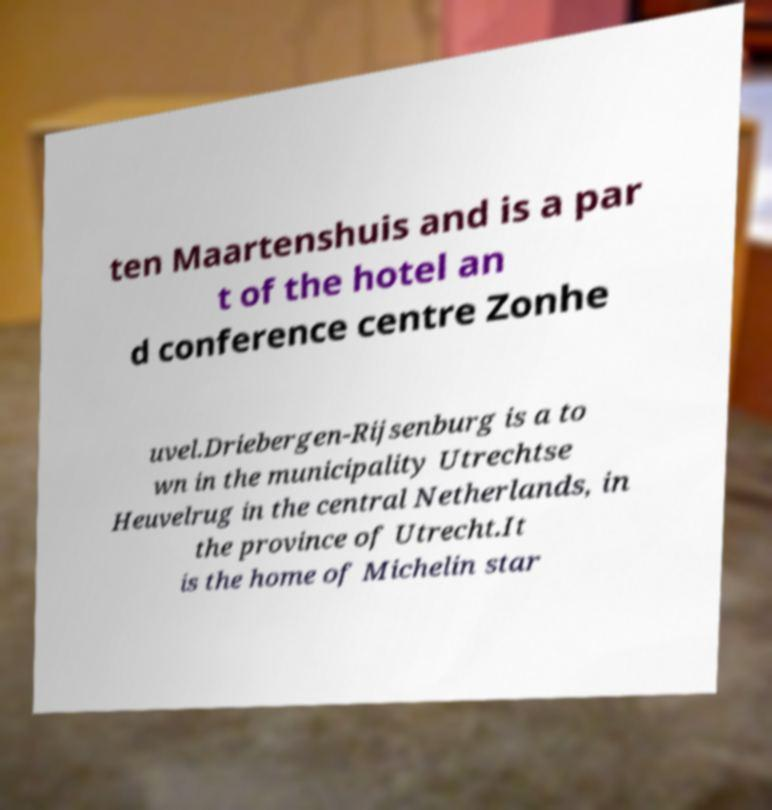I need the written content from this picture converted into text. Can you do that? ten Maartenshuis and is a par t of the hotel an d conference centre Zonhe uvel.Driebergen-Rijsenburg is a to wn in the municipality Utrechtse Heuvelrug in the central Netherlands, in the province of Utrecht.It is the home of Michelin star 